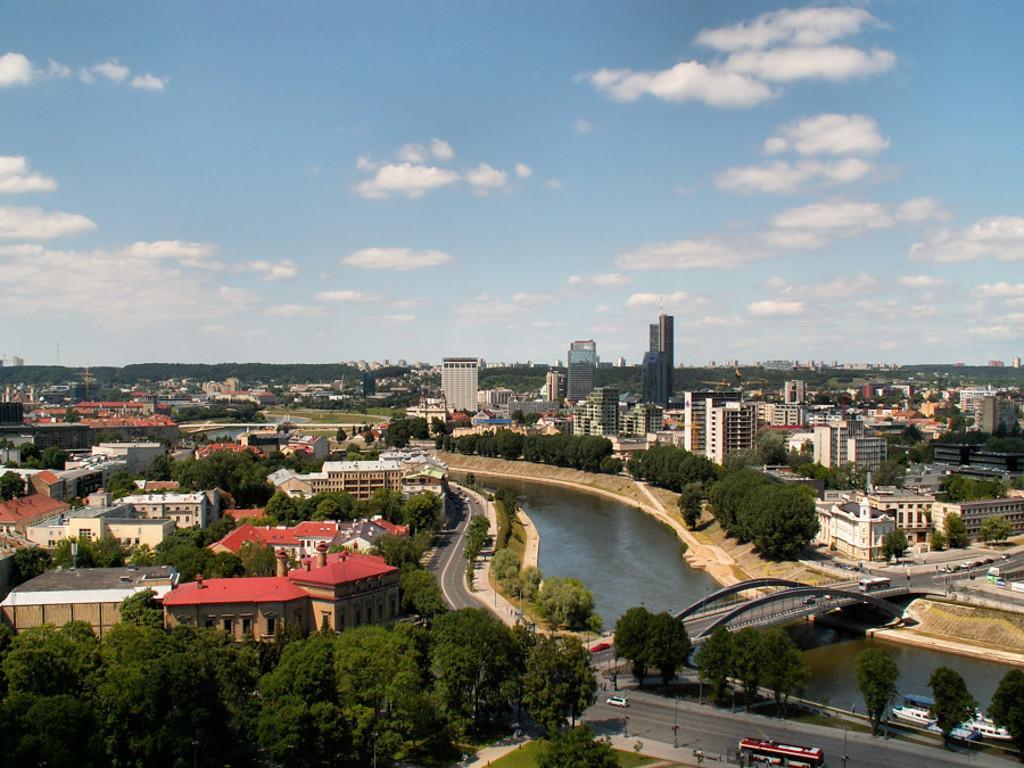Can you describe this image briefly? In this image we can see many buildings and trees. We can also see the bridge, river and some vehicles on the road. At the top there is sky with some clouds. 